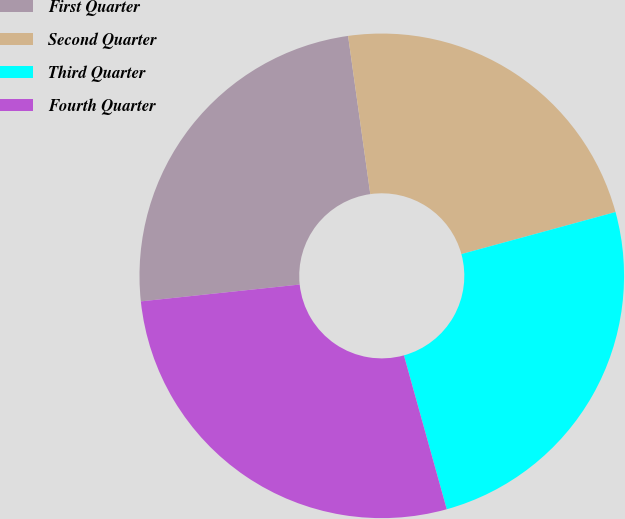<chart> <loc_0><loc_0><loc_500><loc_500><pie_chart><fcel>First Quarter<fcel>Second Quarter<fcel>Third Quarter<fcel>Fourth Quarter<nl><fcel>24.46%<fcel>22.98%<fcel>24.92%<fcel>27.64%<nl></chart> 